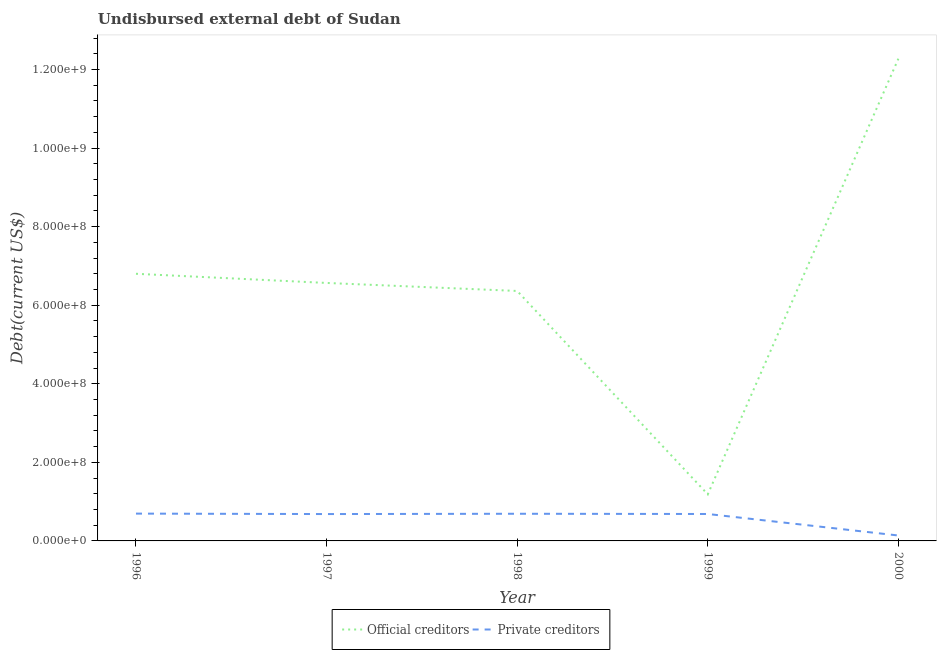How many different coloured lines are there?
Offer a very short reply. 2. Does the line corresponding to undisbursed external debt of official creditors intersect with the line corresponding to undisbursed external debt of private creditors?
Your response must be concise. No. What is the undisbursed external debt of official creditors in 1998?
Offer a very short reply. 6.36e+08. Across all years, what is the maximum undisbursed external debt of official creditors?
Your answer should be very brief. 1.23e+09. Across all years, what is the minimum undisbursed external debt of private creditors?
Provide a short and direct response. 1.38e+07. In which year was the undisbursed external debt of official creditors maximum?
Give a very brief answer. 2000. In which year was the undisbursed external debt of private creditors minimum?
Give a very brief answer. 2000. What is the total undisbursed external debt of private creditors in the graph?
Offer a terse response. 2.89e+08. What is the difference between the undisbursed external debt of private creditors in 1998 and that in 2000?
Make the answer very short. 5.54e+07. What is the difference between the undisbursed external debt of official creditors in 1999 and the undisbursed external debt of private creditors in 2000?
Give a very brief answer. 1.05e+08. What is the average undisbursed external debt of private creditors per year?
Provide a succinct answer. 5.79e+07. In the year 1999, what is the difference between the undisbursed external debt of official creditors and undisbursed external debt of private creditors?
Your response must be concise. 5.00e+07. In how many years, is the undisbursed external debt of official creditors greater than 880000000 US$?
Offer a very short reply. 1. What is the ratio of the undisbursed external debt of private creditors in 1998 to that in 2000?
Offer a very short reply. 5.01. Is the difference between the undisbursed external debt of private creditors in 1997 and 2000 greater than the difference between the undisbursed external debt of official creditors in 1997 and 2000?
Make the answer very short. Yes. What is the difference between the highest and the second highest undisbursed external debt of official creditors?
Provide a short and direct response. 5.48e+08. What is the difference between the highest and the lowest undisbursed external debt of official creditors?
Your answer should be very brief. 1.11e+09. In how many years, is the undisbursed external debt of private creditors greater than the average undisbursed external debt of private creditors taken over all years?
Provide a short and direct response. 4. Is the undisbursed external debt of official creditors strictly greater than the undisbursed external debt of private creditors over the years?
Your response must be concise. Yes. Is the undisbursed external debt of official creditors strictly less than the undisbursed external debt of private creditors over the years?
Keep it short and to the point. No. How many lines are there?
Offer a terse response. 2. How many years are there in the graph?
Offer a terse response. 5. Does the graph contain any zero values?
Your answer should be very brief. No. Does the graph contain grids?
Provide a short and direct response. No. How many legend labels are there?
Offer a very short reply. 2. What is the title of the graph?
Your response must be concise. Undisbursed external debt of Sudan. What is the label or title of the X-axis?
Your response must be concise. Year. What is the label or title of the Y-axis?
Give a very brief answer. Debt(current US$). What is the Debt(current US$) in Official creditors in 1996?
Your answer should be compact. 6.80e+08. What is the Debt(current US$) of Private creditors in 1996?
Provide a short and direct response. 6.95e+07. What is the Debt(current US$) of Official creditors in 1997?
Ensure brevity in your answer.  6.57e+08. What is the Debt(current US$) in Private creditors in 1997?
Make the answer very short. 6.84e+07. What is the Debt(current US$) of Official creditors in 1998?
Ensure brevity in your answer.  6.36e+08. What is the Debt(current US$) in Private creditors in 1998?
Make the answer very short. 6.92e+07. What is the Debt(current US$) in Official creditors in 1999?
Keep it short and to the point. 1.19e+08. What is the Debt(current US$) in Private creditors in 1999?
Your response must be concise. 6.86e+07. What is the Debt(current US$) in Official creditors in 2000?
Give a very brief answer. 1.23e+09. What is the Debt(current US$) of Private creditors in 2000?
Your response must be concise. 1.38e+07. Across all years, what is the maximum Debt(current US$) in Official creditors?
Make the answer very short. 1.23e+09. Across all years, what is the maximum Debt(current US$) of Private creditors?
Provide a short and direct response. 6.95e+07. Across all years, what is the minimum Debt(current US$) of Official creditors?
Provide a succinct answer. 1.19e+08. Across all years, what is the minimum Debt(current US$) in Private creditors?
Offer a terse response. 1.38e+07. What is the total Debt(current US$) of Official creditors in the graph?
Provide a short and direct response. 3.32e+09. What is the total Debt(current US$) of Private creditors in the graph?
Give a very brief answer. 2.89e+08. What is the difference between the Debt(current US$) of Official creditors in 1996 and that in 1997?
Offer a very short reply. 2.33e+07. What is the difference between the Debt(current US$) in Private creditors in 1996 and that in 1997?
Your response must be concise. 1.14e+06. What is the difference between the Debt(current US$) in Official creditors in 1996 and that in 1998?
Your answer should be very brief. 4.37e+07. What is the difference between the Debt(current US$) in Private creditors in 1996 and that in 1998?
Keep it short and to the point. 3.85e+05. What is the difference between the Debt(current US$) of Official creditors in 1996 and that in 1999?
Ensure brevity in your answer.  5.62e+08. What is the difference between the Debt(current US$) in Private creditors in 1996 and that in 1999?
Provide a succinct answer. 9.80e+05. What is the difference between the Debt(current US$) of Official creditors in 1996 and that in 2000?
Your answer should be very brief. -5.48e+08. What is the difference between the Debt(current US$) of Private creditors in 1996 and that in 2000?
Keep it short and to the point. 5.57e+07. What is the difference between the Debt(current US$) of Official creditors in 1997 and that in 1998?
Give a very brief answer. 2.04e+07. What is the difference between the Debt(current US$) in Private creditors in 1997 and that in 1998?
Provide a short and direct response. -7.58e+05. What is the difference between the Debt(current US$) in Official creditors in 1997 and that in 1999?
Your response must be concise. 5.38e+08. What is the difference between the Debt(current US$) in Private creditors in 1997 and that in 1999?
Ensure brevity in your answer.  -1.63e+05. What is the difference between the Debt(current US$) of Official creditors in 1997 and that in 2000?
Offer a terse response. -5.71e+08. What is the difference between the Debt(current US$) of Private creditors in 1997 and that in 2000?
Your answer should be compact. 5.46e+07. What is the difference between the Debt(current US$) in Official creditors in 1998 and that in 1999?
Provide a short and direct response. 5.18e+08. What is the difference between the Debt(current US$) in Private creditors in 1998 and that in 1999?
Provide a succinct answer. 5.95e+05. What is the difference between the Debt(current US$) in Official creditors in 1998 and that in 2000?
Ensure brevity in your answer.  -5.91e+08. What is the difference between the Debt(current US$) in Private creditors in 1998 and that in 2000?
Keep it short and to the point. 5.54e+07. What is the difference between the Debt(current US$) of Official creditors in 1999 and that in 2000?
Provide a short and direct response. -1.11e+09. What is the difference between the Debt(current US$) in Private creditors in 1999 and that in 2000?
Provide a short and direct response. 5.48e+07. What is the difference between the Debt(current US$) in Official creditors in 1996 and the Debt(current US$) in Private creditors in 1997?
Your answer should be very brief. 6.12e+08. What is the difference between the Debt(current US$) of Official creditors in 1996 and the Debt(current US$) of Private creditors in 1998?
Keep it short and to the point. 6.11e+08. What is the difference between the Debt(current US$) in Official creditors in 1996 and the Debt(current US$) in Private creditors in 1999?
Give a very brief answer. 6.12e+08. What is the difference between the Debt(current US$) of Official creditors in 1996 and the Debt(current US$) of Private creditors in 2000?
Ensure brevity in your answer.  6.66e+08. What is the difference between the Debt(current US$) of Official creditors in 1997 and the Debt(current US$) of Private creditors in 1998?
Offer a very short reply. 5.88e+08. What is the difference between the Debt(current US$) of Official creditors in 1997 and the Debt(current US$) of Private creditors in 1999?
Provide a short and direct response. 5.88e+08. What is the difference between the Debt(current US$) in Official creditors in 1997 and the Debt(current US$) in Private creditors in 2000?
Provide a short and direct response. 6.43e+08. What is the difference between the Debt(current US$) of Official creditors in 1998 and the Debt(current US$) of Private creditors in 1999?
Your answer should be compact. 5.68e+08. What is the difference between the Debt(current US$) of Official creditors in 1998 and the Debt(current US$) of Private creditors in 2000?
Provide a succinct answer. 6.23e+08. What is the difference between the Debt(current US$) of Official creditors in 1999 and the Debt(current US$) of Private creditors in 2000?
Your response must be concise. 1.05e+08. What is the average Debt(current US$) of Official creditors per year?
Ensure brevity in your answer.  6.64e+08. What is the average Debt(current US$) in Private creditors per year?
Your response must be concise. 5.79e+07. In the year 1996, what is the difference between the Debt(current US$) of Official creditors and Debt(current US$) of Private creditors?
Your answer should be very brief. 6.11e+08. In the year 1997, what is the difference between the Debt(current US$) of Official creditors and Debt(current US$) of Private creditors?
Give a very brief answer. 5.88e+08. In the year 1998, what is the difference between the Debt(current US$) in Official creditors and Debt(current US$) in Private creditors?
Provide a short and direct response. 5.67e+08. In the year 1999, what is the difference between the Debt(current US$) in Official creditors and Debt(current US$) in Private creditors?
Ensure brevity in your answer.  5.00e+07. In the year 2000, what is the difference between the Debt(current US$) of Official creditors and Debt(current US$) of Private creditors?
Offer a terse response. 1.21e+09. What is the ratio of the Debt(current US$) in Official creditors in 1996 to that in 1997?
Provide a succinct answer. 1.04. What is the ratio of the Debt(current US$) of Private creditors in 1996 to that in 1997?
Your response must be concise. 1.02. What is the ratio of the Debt(current US$) in Official creditors in 1996 to that in 1998?
Your answer should be very brief. 1.07. What is the ratio of the Debt(current US$) in Private creditors in 1996 to that in 1998?
Offer a very short reply. 1.01. What is the ratio of the Debt(current US$) of Official creditors in 1996 to that in 1999?
Your response must be concise. 5.74. What is the ratio of the Debt(current US$) in Private creditors in 1996 to that in 1999?
Offer a terse response. 1.01. What is the ratio of the Debt(current US$) of Official creditors in 1996 to that in 2000?
Your answer should be compact. 0.55. What is the ratio of the Debt(current US$) in Private creditors in 1996 to that in 2000?
Your answer should be compact. 5.04. What is the ratio of the Debt(current US$) in Official creditors in 1997 to that in 1998?
Keep it short and to the point. 1.03. What is the ratio of the Debt(current US$) of Private creditors in 1997 to that in 1998?
Ensure brevity in your answer.  0.99. What is the ratio of the Debt(current US$) of Official creditors in 1997 to that in 1999?
Keep it short and to the point. 5.54. What is the ratio of the Debt(current US$) of Official creditors in 1997 to that in 2000?
Your response must be concise. 0.54. What is the ratio of the Debt(current US$) in Private creditors in 1997 to that in 2000?
Your answer should be very brief. 4.96. What is the ratio of the Debt(current US$) of Official creditors in 1998 to that in 1999?
Your answer should be very brief. 5.37. What is the ratio of the Debt(current US$) in Private creditors in 1998 to that in 1999?
Offer a very short reply. 1.01. What is the ratio of the Debt(current US$) of Official creditors in 1998 to that in 2000?
Ensure brevity in your answer.  0.52. What is the ratio of the Debt(current US$) of Private creditors in 1998 to that in 2000?
Provide a short and direct response. 5.01. What is the ratio of the Debt(current US$) of Official creditors in 1999 to that in 2000?
Your answer should be very brief. 0.1. What is the ratio of the Debt(current US$) of Private creditors in 1999 to that in 2000?
Provide a succinct answer. 4.97. What is the difference between the highest and the second highest Debt(current US$) in Official creditors?
Your response must be concise. 5.48e+08. What is the difference between the highest and the second highest Debt(current US$) in Private creditors?
Your response must be concise. 3.85e+05. What is the difference between the highest and the lowest Debt(current US$) of Official creditors?
Give a very brief answer. 1.11e+09. What is the difference between the highest and the lowest Debt(current US$) in Private creditors?
Offer a terse response. 5.57e+07. 